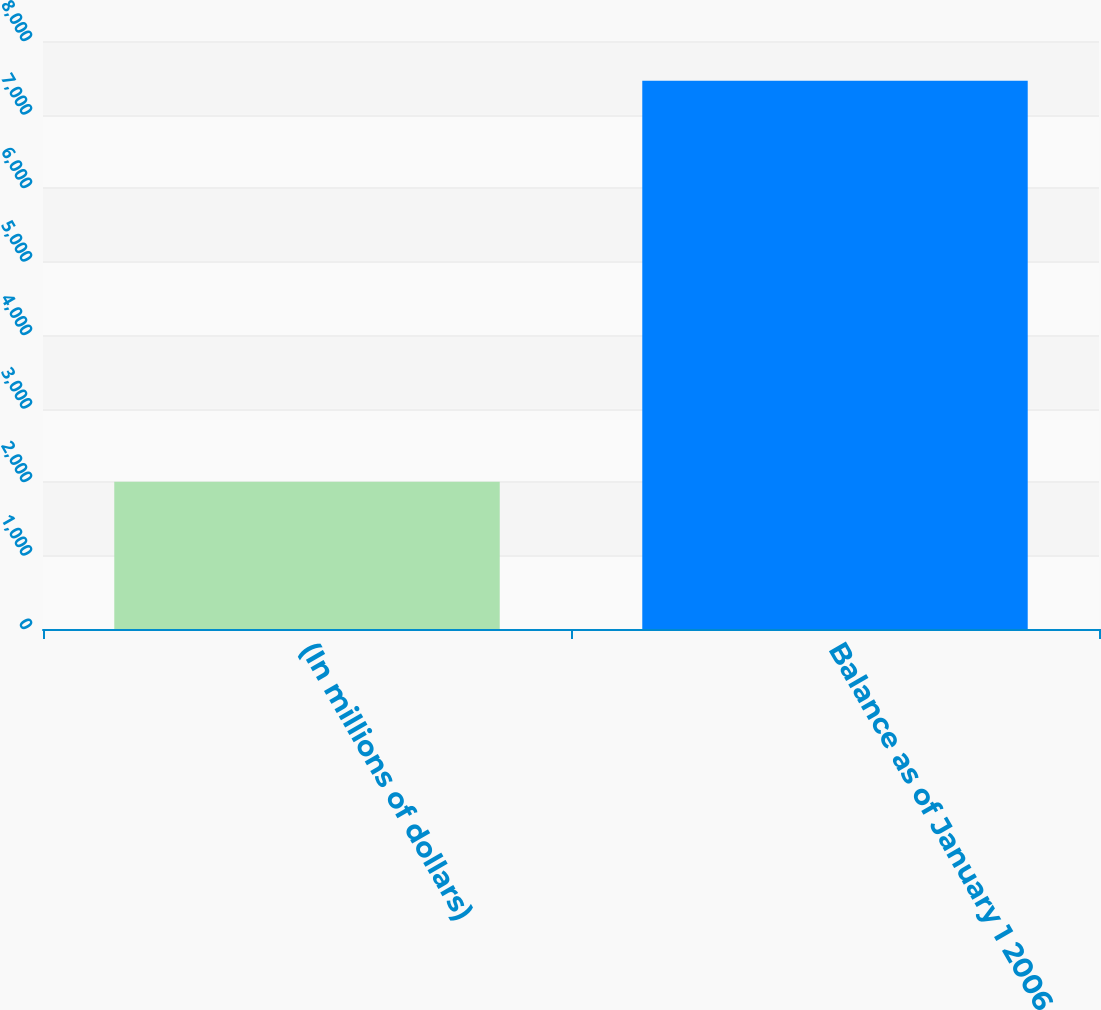Convert chart. <chart><loc_0><loc_0><loc_500><loc_500><bar_chart><fcel>(In millions of dollars)<fcel>Balance as of January 1 2006<nl><fcel>2005<fcel>7459<nl></chart> 